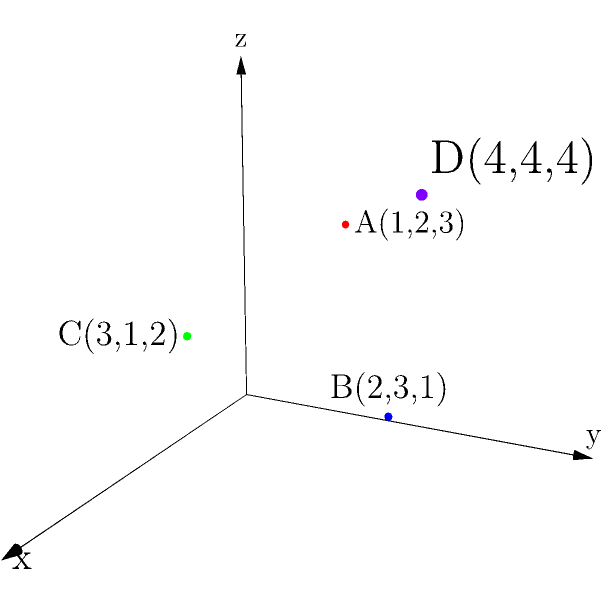As an experienced online seller, you are tasked with determining the optimal placement of a new distribution center. Four potential locations (A, B, C, and D) have been identified, represented by points in a 3D coordinate system as shown in the diagram. The coordinates represent distance from major highways (x-axis), proximity to urban centers (y-axis), and available warehouse space (z-axis) in arbitrary units. Which location would you choose to minimize the total distance from the distribution center to all other points, ensuring efficient shipping and excellent product quality? To determine the optimal placement of the distribution center, we need to calculate the point that minimizes the total distance to all other points. This point is known as the geometric median or 1-median. While there's no simple formula to calculate this exactly, we can approximate it by finding the coordinate-wise median.

Step 1: List all coordinates for each axis:
x-coordinates: 1, 2, 3, 4
y-coordinates: 2, 3, 1, 4
z-coordinates: 3, 1, 2, 4

Step 2: Find the median for each axis:
x-median: (2 + 3) / 2 = 2.5
y-median: (2 + 3) / 2 = 2.5
z-median: (2 + 3) / 2 = 2.5

Step 3: The approximate optimal point is (2.5, 2.5, 2.5).

Step 4: Calculate the distance from this point to each given point using the 3D distance formula:
$$d = \sqrt{(x_2-x_1)^2 + (y_2-y_1)^2 + (z_2-z_1)^2}$$

Step 5: Compare these distances to the distances between each given point:

A(1,2,3) is closest to the optimal point (2.5, 2.5, 2.5)
B(2,3,1) is second closest
C(3,1,2) is third closest
D(4,4,4) is furthest

Therefore, point A(1,2,3) is the best choice among the given options, as it's closest to the calculated optimal point and will minimize the total distance to all other points.
Answer: A(1,2,3) 